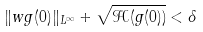Convert formula to latex. <formula><loc_0><loc_0><loc_500><loc_500>\| w g ( 0 ) \| _ { L ^ { \infty } } + \sqrt { \mathcal { H } ( g ( 0 ) ) } < \delta</formula> 